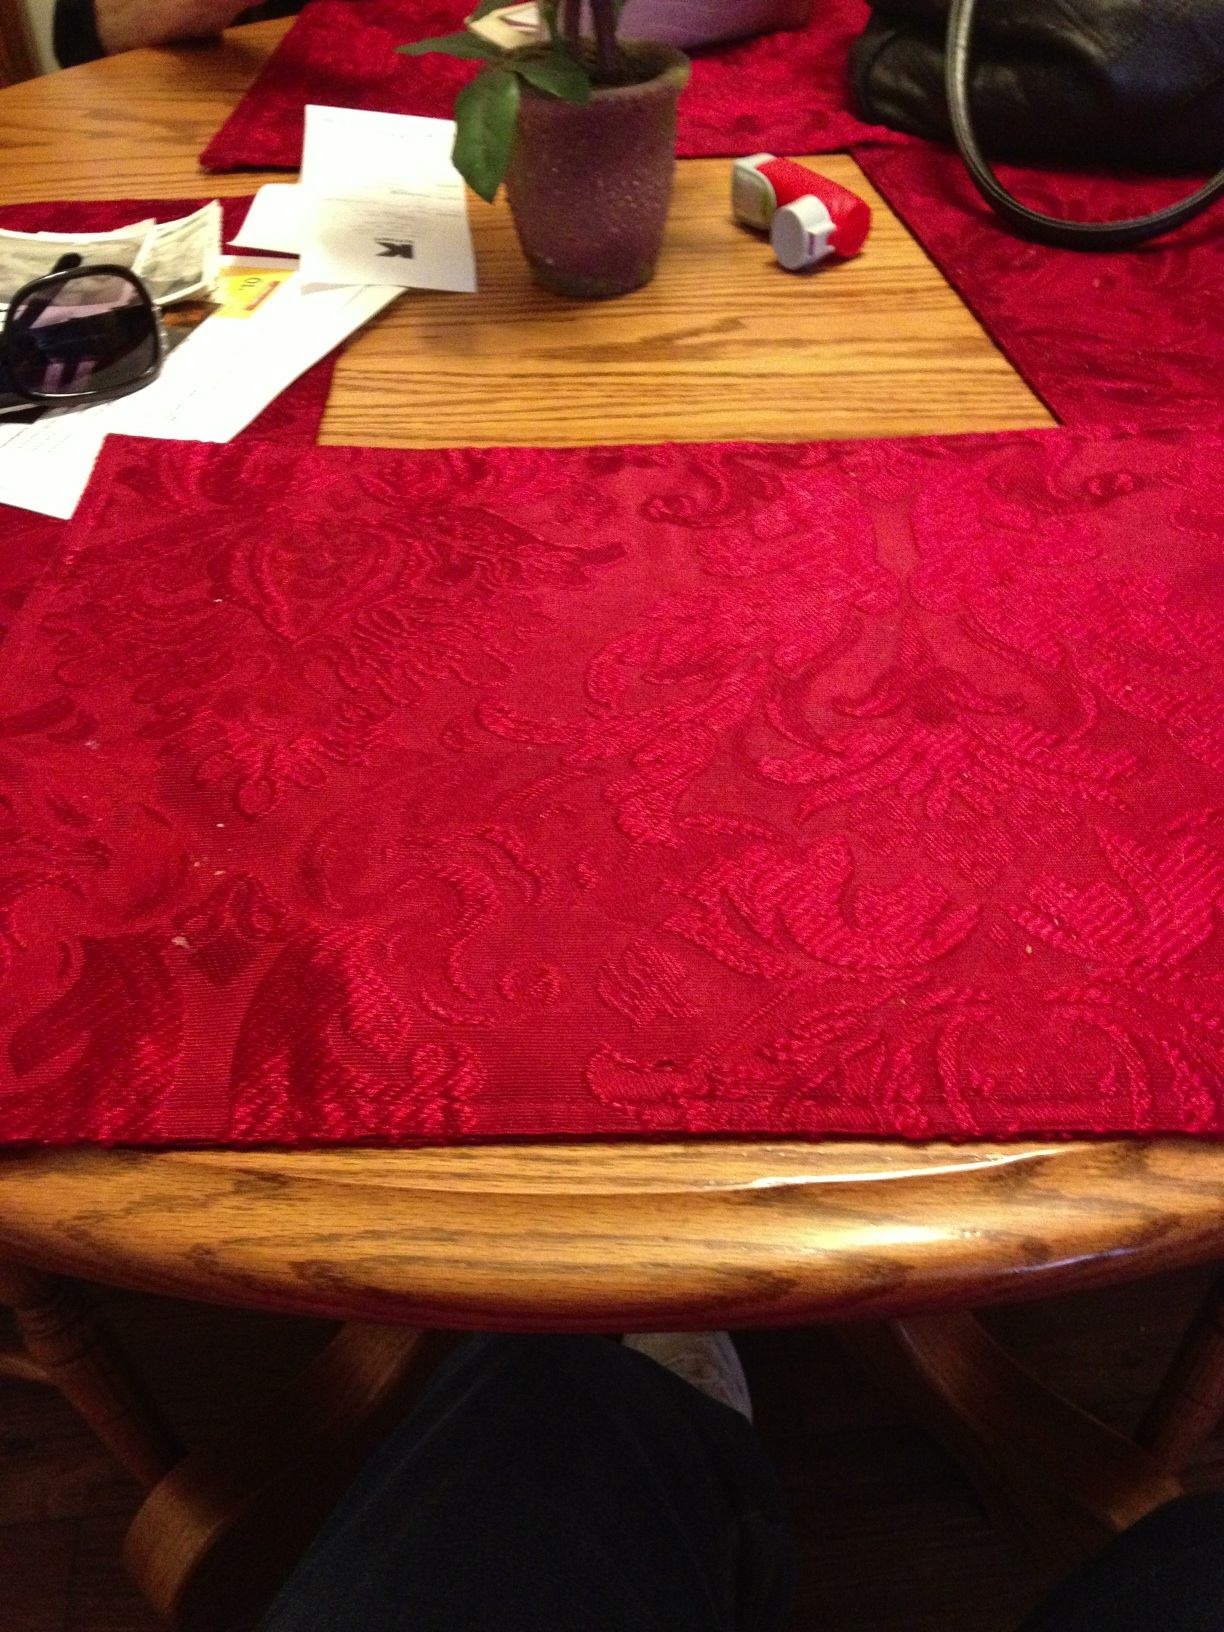What does the arrangement on the table tell us about the setting? The arrangement on the table communicates a casual and lived-in space, likely a home environment. The mixture of everyday items, like the sunglasses and purse, along with the domestic touch of the houseplant, implies that the table is a central point where items are placed throughout the day. It is a functional space that sees regular use, not just a decorative area. 